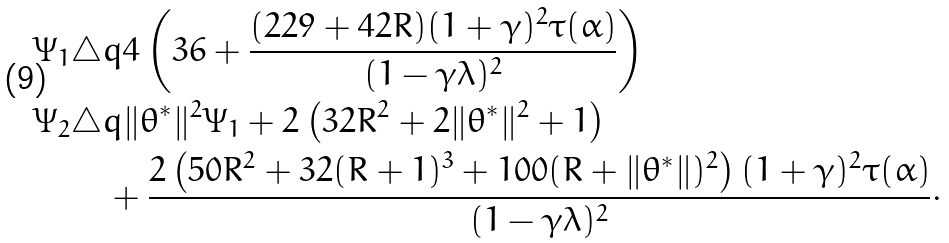Convert formula to latex. <formula><loc_0><loc_0><loc_500><loc_500>\Psi _ { 1 } & \triangle q 4 \left ( 3 6 + \frac { ( 2 2 9 + 4 2 R ) ( 1 + \gamma ) ^ { 2 } \tau ( \alpha ) } { ( 1 - \gamma \lambda ) ^ { 2 } } \right ) \\ \Psi _ { 2 } & \triangle q \| \theta ^ { * } \| ^ { 2 } \Psi _ { 1 } + 2 \left ( 3 2 R ^ { 2 } + 2 \| \theta ^ { * } \| ^ { 2 } + 1 \right ) \\ & \quad + \frac { 2 \left ( 5 0 R ^ { 2 } + 3 2 ( R + 1 ) ^ { 3 } + 1 0 0 ( R + \| \theta ^ { * } \| ) ^ { 2 } \right ) ( 1 + \gamma ) ^ { 2 } \tau ( \alpha ) } { ( 1 - \gamma \lambda ) ^ { 2 } } \cdot</formula> 